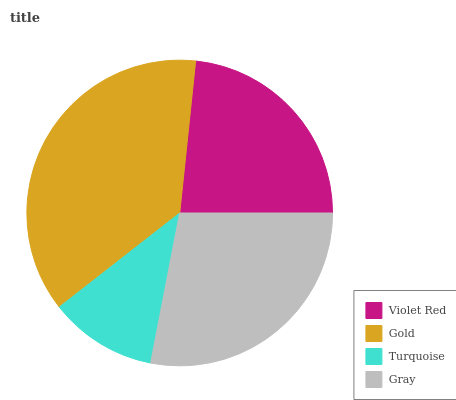Is Turquoise the minimum?
Answer yes or no. Yes. Is Gold the maximum?
Answer yes or no. Yes. Is Gold the minimum?
Answer yes or no. No. Is Turquoise the maximum?
Answer yes or no. No. Is Gold greater than Turquoise?
Answer yes or no. Yes. Is Turquoise less than Gold?
Answer yes or no. Yes. Is Turquoise greater than Gold?
Answer yes or no. No. Is Gold less than Turquoise?
Answer yes or no. No. Is Gray the high median?
Answer yes or no. Yes. Is Violet Red the low median?
Answer yes or no. Yes. Is Violet Red the high median?
Answer yes or no. No. Is Gray the low median?
Answer yes or no. No. 